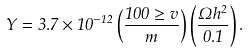Convert formula to latex. <formula><loc_0><loc_0><loc_500><loc_500>Y = 3 . 7 \times 1 0 ^ { - 1 2 } \left ( \frac { 1 0 0 \geq v } { m } \right ) \left ( \frac { \Omega h ^ { 2 } } { 0 . 1 } \right ) .</formula> 